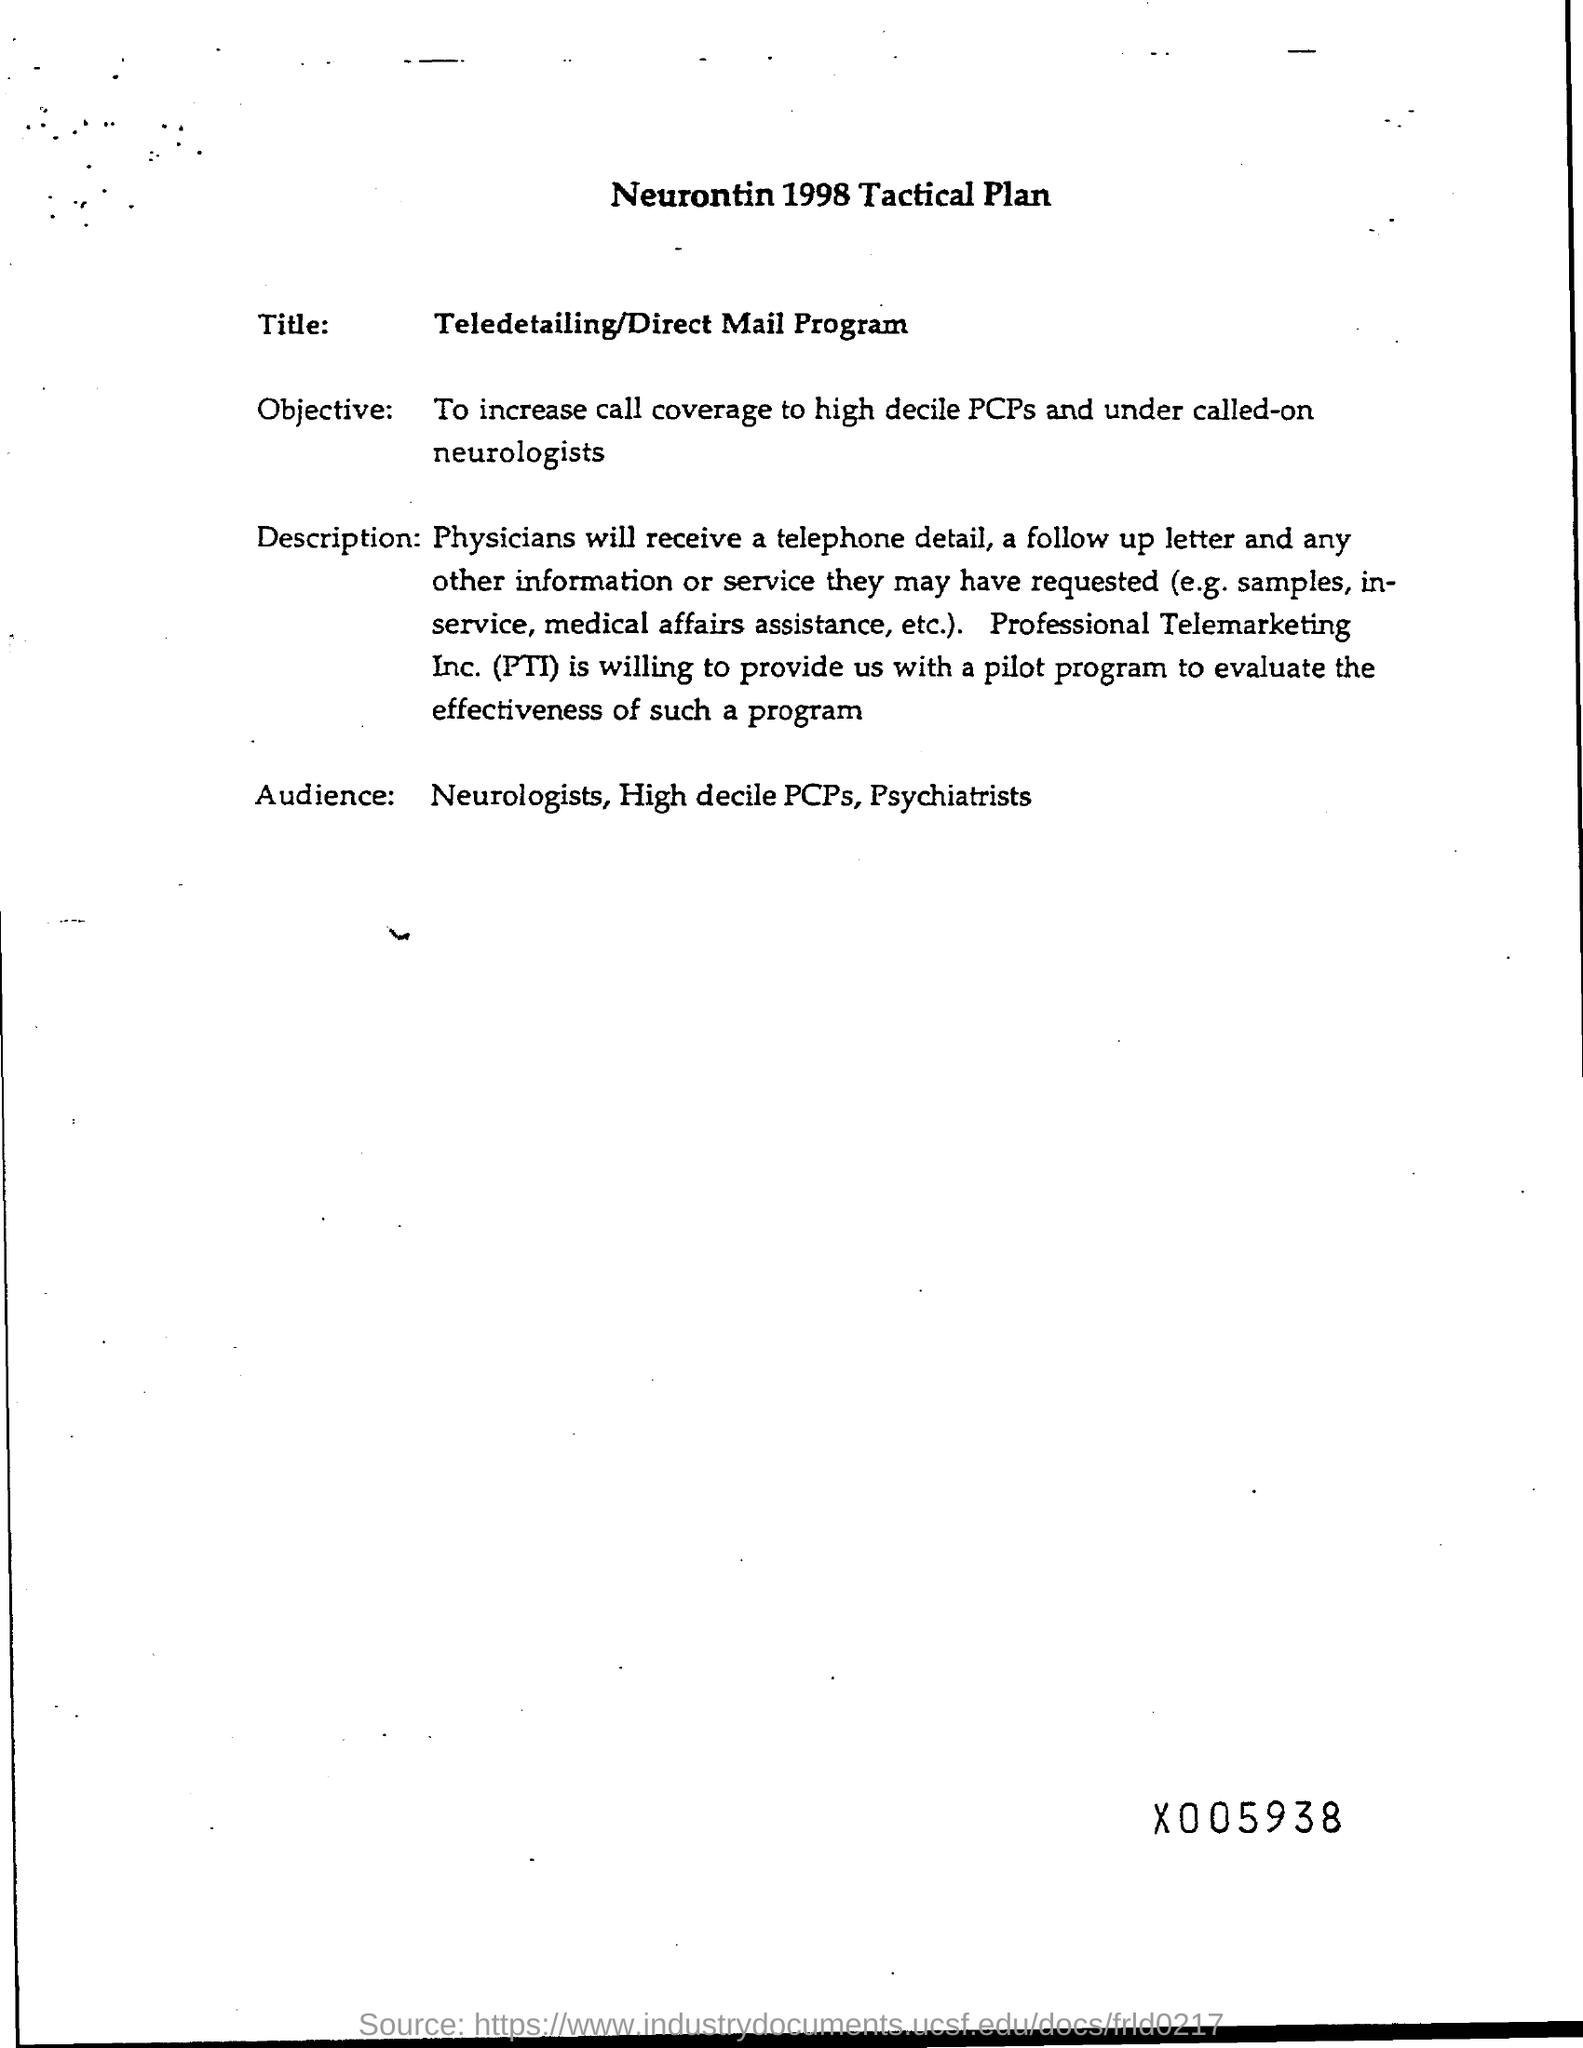Identify some key points in this picture. The heading of the document mentions the year 1998. Professional Telemarketing, Inc. is a company that provides services related to telemarketing and telephone sales. The intended audience for this training includes neurologists, high-decile primary care physicians, and psychiatrists. Our objective is to increase call coverage for high decile primary care physicians (PCPs) and under-called-on neurologists in order to improve patient care and satisfaction. The title of this document is the Teledetailing/Direct Mail Program. 